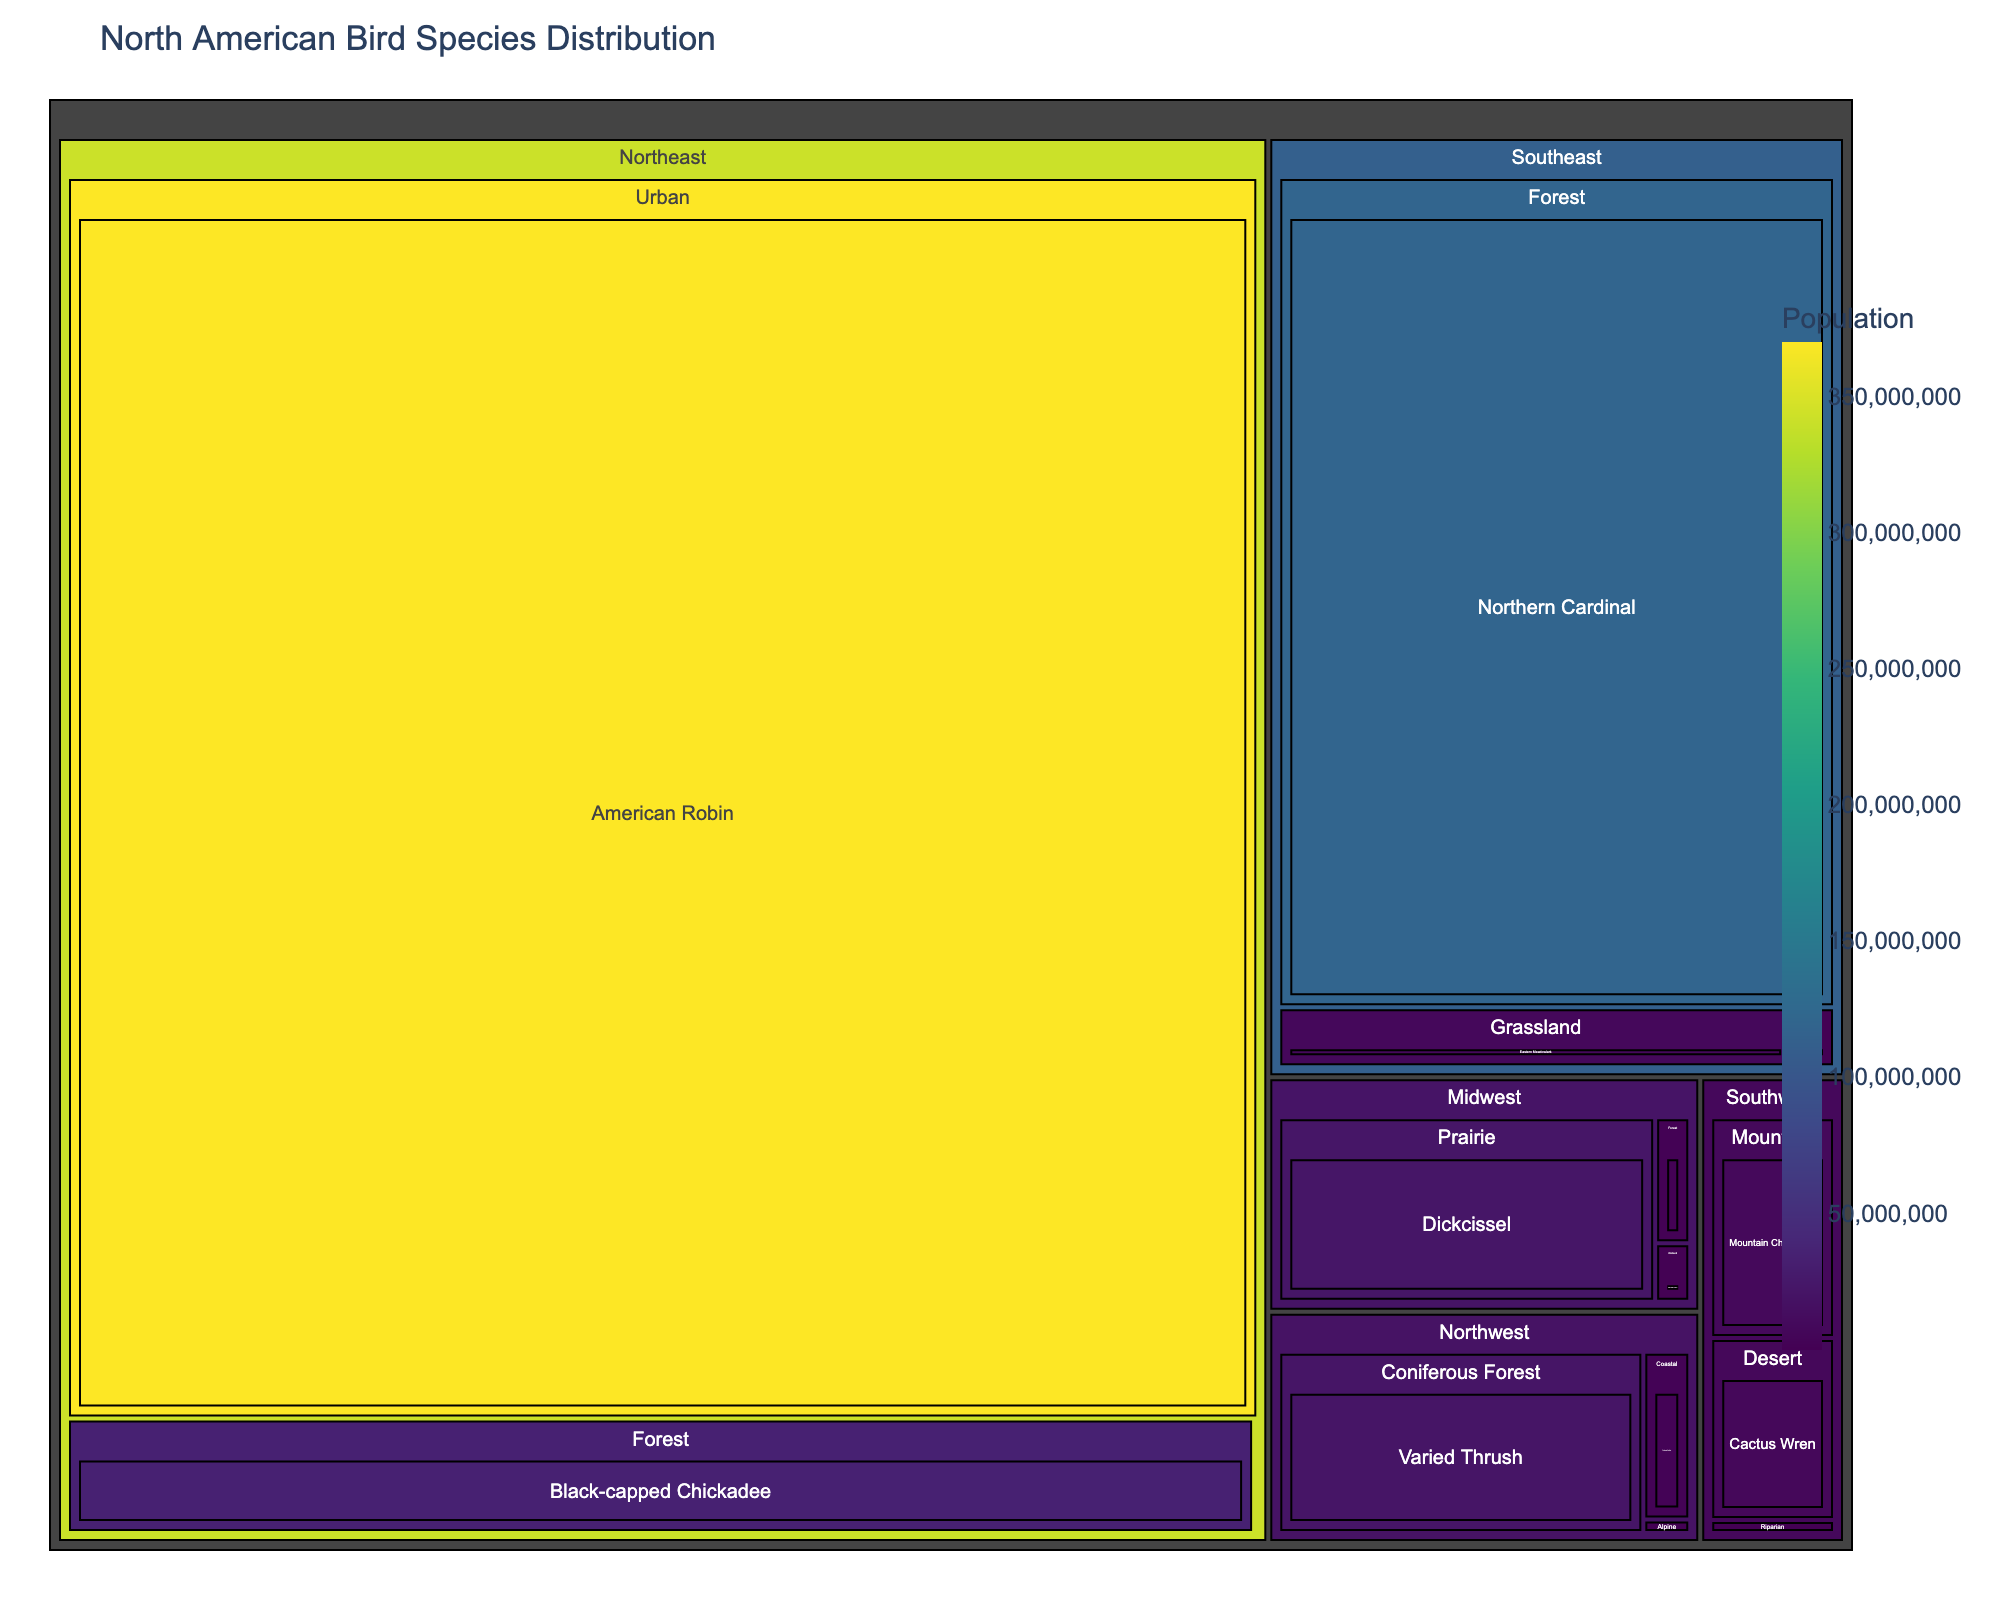what is the total population of bird species in Northeast? To calculate the total population in the Northeast region, sum the populations of the Black-capped Chickadee, Great Blue Heron, and American Robin. 34,000,000 + 120,000 + 370,000,000 = 404,120,000.
Answer: 404,120,000 which region has the highest population of bird species? Compare the total population values of various regional sections in the treemap. The Northeast region, with a population of 404,120,000, surpasses all other regions.
Answer: Northeast What bird species has the smallest population in the Northwest region? In the Northwest region, check the populations for each species and select the lowest one. The Gray-crowned Rosy-Finch has the smallest population with 200,000.
Answer: Gray-crowned Rosy-Finch which habitat type in the Southeast region has the highest population of bird species? In the Southeast region, compare the populations across habitats: Coastal, Forest, and Grassland. The Forest habitat has the highest population with Northern Cardinal at 120,000,000.
Answer: Forest How many species are listed in the treemap for the Southwest region? Check the treemap's breakdown for the Southwest region and count the number of species listed: Cactus Wren, Mountain Chickadee, Vermilion Flycatcher— a total of three species.
Answer: 3 what is the combined population of forest habitat types across all regions? Sum the populations in the forest habitats from all regions: Black-capped Chickadee (Northeast) + Northern Cardinal (Southeast) + Red-headed Woodpecker (Midwest) + Varied Thrush (Northwest). Calculation: 34,000,000 + 120,000,000 + 1,400,000 + 21,000,000 = 176,400,000.
Answer: 176,400,000 Which bird species in the Midwest region has a population greater than 1,000,000? Look at the Midwest region in the treemap and filter out bird species with populations over 1,000,000. Both Dickcissel and Red-headed Woodpecker qualify with 22,000,000 and 1,400,000 respectively.
Answer: Dickcissel, Red-headed Woodpecker which species in the Northwest coastal habitat has a higher population, Tufted Puffin or Gray-crowned Rosy-Finch? Compare the populations of the Tufted Puffin and Gray-crowned Rosy-Finch. Tufted Puffin has 2,500,000, while Gray-crowned Rosy-Finch has 200,000.
Answer: Tufted Puffin 